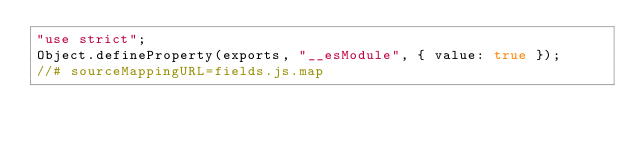Convert code to text. <code><loc_0><loc_0><loc_500><loc_500><_JavaScript_>"use strict";
Object.defineProperty(exports, "__esModule", { value: true });
//# sourceMappingURL=fields.js.map</code> 